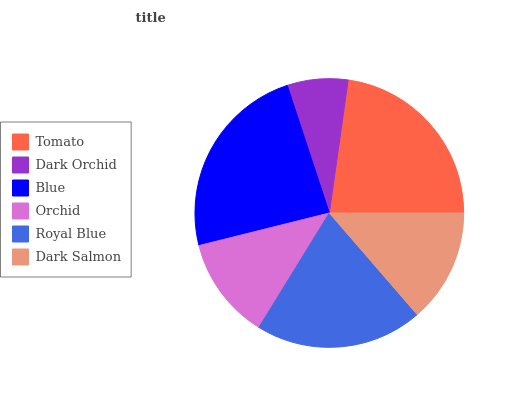Is Dark Orchid the minimum?
Answer yes or no. Yes. Is Blue the maximum?
Answer yes or no. Yes. Is Blue the minimum?
Answer yes or no. No. Is Dark Orchid the maximum?
Answer yes or no. No. Is Blue greater than Dark Orchid?
Answer yes or no. Yes. Is Dark Orchid less than Blue?
Answer yes or no. Yes. Is Dark Orchid greater than Blue?
Answer yes or no. No. Is Blue less than Dark Orchid?
Answer yes or no. No. Is Royal Blue the high median?
Answer yes or no. Yes. Is Dark Salmon the low median?
Answer yes or no. Yes. Is Dark Orchid the high median?
Answer yes or no. No. Is Orchid the low median?
Answer yes or no. No. 